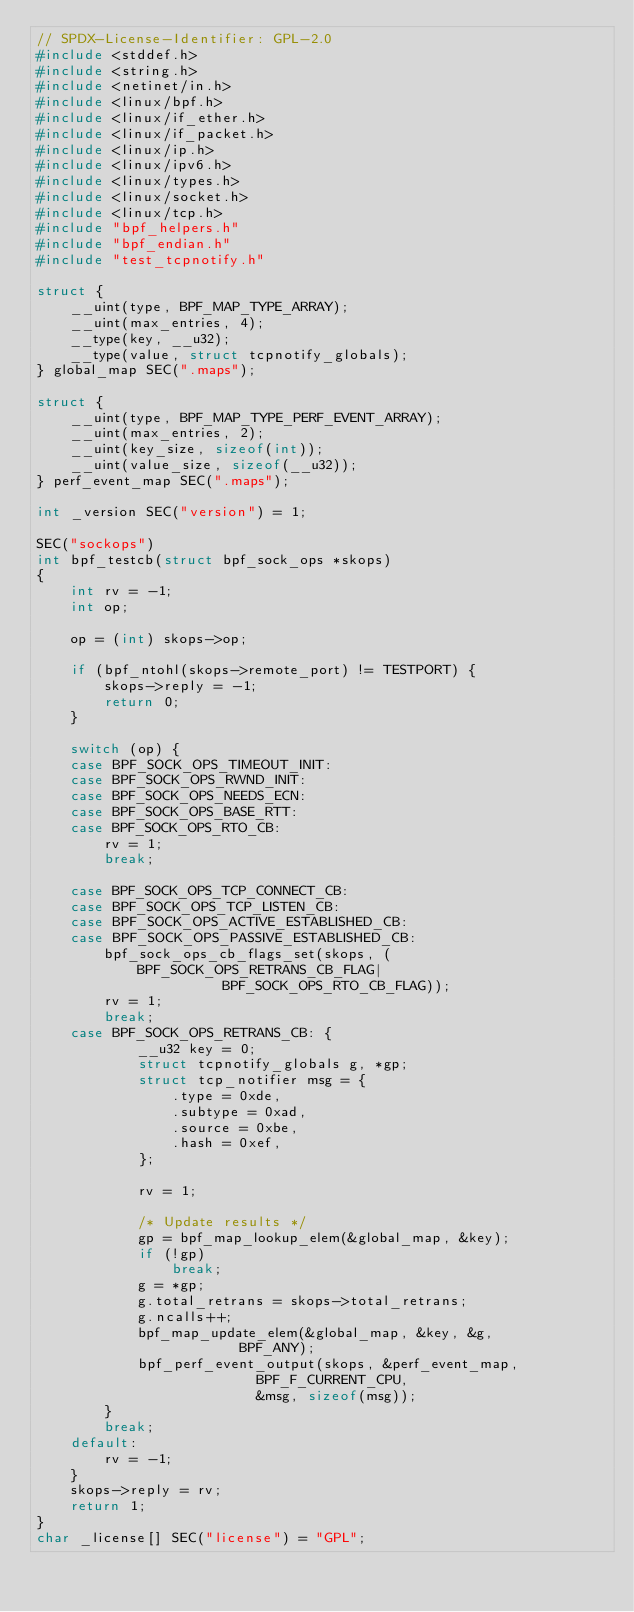<code> <loc_0><loc_0><loc_500><loc_500><_C_>// SPDX-License-Identifier: GPL-2.0
#include <stddef.h>
#include <string.h>
#include <netinet/in.h>
#include <linux/bpf.h>
#include <linux/if_ether.h>
#include <linux/if_packet.h>
#include <linux/ip.h>
#include <linux/ipv6.h>
#include <linux/types.h>
#include <linux/socket.h>
#include <linux/tcp.h>
#include "bpf_helpers.h"
#include "bpf_endian.h"
#include "test_tcpnotify.h"

struct {
	__uint(type, BPF_MAP_TYPE_ARRAY);
	__uint(max_entries, 4);
	__type(key, __u32);
	__type(value, struct tcpnotify_globals);
} global_map SEC(".maps");

struct {
	__uint(type, BPF_MAP_TYPE_PERF_EVENT_ARRAY);
	__uint(max_entries, 2);
	__uint(key_size, sizeof(int));
	__uint(value_size, sizeof(__u32));
} perf_event_map SEC(".maps");

int _version SEC("version") = 1;

SEC("sockops")
int bpf_testcb(struct bpf_sock_ops *skops)
{
	int rv = -1;
	int op;

	op = (int) skops->op;

	if (bpf_ntohl(skops->remote_port) != TESTPORT) {
		skops->reply = -1;
		return 0;
	}

	switch (op) {
	case BPF_SOCK_OPS_TIMEOUT_INIT:
	case BPF_SOCK_OPS_RWND_INIT:
	case BPF_SOCK_OPS_NEEDS_ECN:
	case BPF_SOCK_OPS_BASE_RTT:
	case BPF_SOCK_OPS_RTO_CB:
		rv = 1;
		break;

	case BPF_SOCK_OPS_TCP_CONNECT_CB:
	case BPF_SOCK_OPS_TCP_LISTEN_CB:
	case BPF_SOCK_OPS_ACTIVE_ESTABLISHED_CB:
	case BPF_SOCK_OPS_PASSIVE_ESTABLISHED_CB:
		bpf_sock_ops_cb_flags_set(skops, (BPF_SOCK_OPS_RETRANS_CB_FLAG|
					  BPF_SOCK_OPS_RTO_CB_FLAG));
		rv = 1;
		break;
	case BPF_SOCK_OPS_RETRANS_CB: {
			__u32 key = 0;
			struct tcpnotify_globals g, *gp;
			struct tcp_notifier msg = {
				.type = 0xde,
				.subtype = 0xad,
				.source = 0xbe,
				.hash = 0xef,
			};

			rv = 1;

			/* Update results */
			gp = bpf_map_lookup_elem(&global_map, &key);
			if (!gp)
				break;
			g = *gp;
			g.total_retrans = skops->total_retrans;
			g.ncalls++;
			bpf_map_update_elem(&global_map, &key, &g,
					    BPF_ANY);
			bpf_perf_event_output(skops, &perf_event_map,
					      BPF_F_CURRENT_CPU,
					      &msg, sizeof(msg));
		}
		break;
	default:
		rv = -1;
	}
	skops->reply = rv;
	return 1;
}
char _license[] SEC("license") = "GPL";
</code> 